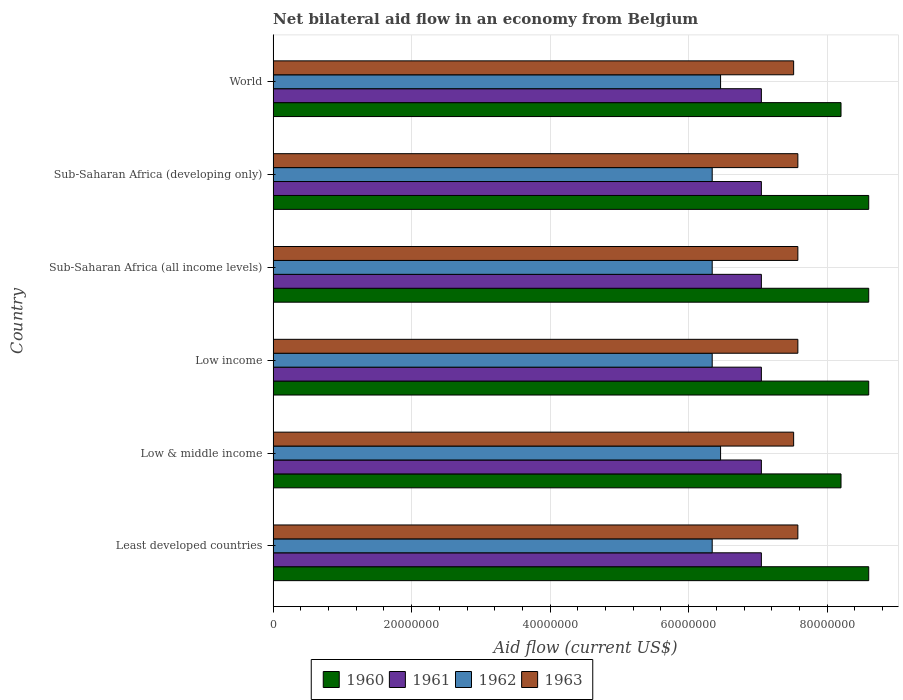How many different coloured bars are there?
Offer a terse response. 4. How many groups of bars are there?
Your response must be concise. 6. Are the number of bars on each tick of the Y-axis equal?
Keep it short and to the point. Yes. What is the label of the 3rd group of bars from the top?
Offer a very short reply. Sub-Saharan Africa (all income levels). What is the net bilateral aid flow in 1960 in Low income?
Your response must be concise. 8.60e+07. Across all countries, what is the maximum net bilateral aid flow in 1963?
Keep it short and to the point. 7.58e+07. Across all countries, what is the minimum net bilateral aid flow in 1960?
Provide a short and direct response. 8.20e+07. In which country was the net bilateral aid flow in 1960 maximum?
Ensure brevity in your answer.  Least developed countries. In which country was the net bilateral aid flow in 1960 minimum?
Your answer should be compact. Low & middle income. What is the total net bilateral aid flow in 1963 in the graph?
Your answer should be very brief. 4.53e+08. What is the difference between the net bilateral aid flow in 1961 in World and the net bilateral aid flow in 1962 in Low income?
Provide a succinct answer. 7.10e+06. What is the average net bilateral aid flow in 1962 per country?
Your response must be concise. 6.38e+07. What is the difference between the net bilateral aid flow in 1962 and net bilateral aid flow in 1960 in Sub-Saharan Africa (all income levels)?
Keep it short and to the point. -2.26e+07. In how many countries, is the net bilateral aid flow in 1962 greater than 72000000 US$?
Ensure brevity in your answer.  0. Is the difference between the net bilateral aid flow in 1962 in Sub-Saharan Africa (all income levels) and World greater than the difference between the net bilateral aid flow in 1960 in Sub-Saharan Africa (all income levels) and World?
Your answer should be very brief. No. What is the difference between the highest and the second highest net bilateral aid flow in 1961?
Give a very brief answer. 0. What is the difference between the highest and the lowest net bilateral aid flow in 1962?
Offer a terse response. 1.21e+06. Is the sum of the net bilateral aid flow in 1962 in Sub-Saharan Africa (all income levels) and World greater than the maximum net bilateral aid flow in 1961 across all countries?
Make the answer very short. Yes. What does the 4th bar from the top in Sub-Saharan Africa (developing only) represents?
Your response must be concise. 1960. Are all the bars in the graph horizontal?
Keep it short and to the point. Yes. What is the difference between two consecutive major ticks on the X-axis?
Your answer should be very brief. 2.00e+07. Does the graph contain grids?
Offer a terse response. Yes. Where does the legend appear in the graph?
Make the answer very short. Bottom center. How many legend labels are there?
Keep it short and to the point. 4. How are the legend labels stacked?
Give a very brief answer. Horizontal. What is the title of the graph?
Give a very brief answer. Net bilateral aid flow in an economy from Belgium. Does "1991" appear as one of the legend labels in the graph?
Provide a short and direct response. No. What is the label or title of the Y-axis?
Provide a succinct answer. Country. What is the Aid flow (current US$) of 1960 in Least developed countries?
Provide a short and direct response. 8.60e+07. What is the Aid flow (current US$) of 1961 in Least developed countries?
Provide a succinct answer. 7.05e+07. What is the Aid flow (current US$) of 1962 in Least developed countries?
Make the answer very short. 6.34e+07. What is the Aid flow (current US$) of 1963 in Least developed countries?
Ensure brevity in your answer.  7.58e+07. What is the Aid flow (current US$) of 1960 in Low & middle income?
Ensure brevity in your answer.  8.20e+07. What is the Aid flow (current US$) of 1961 in Low & middle income?
Offer a very short reply. 7.05e+07. What is the Aid flow (current US$) in 1962 in Low & middle income?
Provide a short and direct response. 6.46e+07. What is the Aid flow (current US$) of 1963 in Low & middle income?
Provide a succinct answer. 7.52e+07. What is the Aid flow (current US$) in 1960 in Low income?
Ensure brevity in your answer.  8.60e+07. What is the Aid flow (current US$) in 1961 in Low income?
Give a very brief answer. 7.05e+07. What is the Aid flow (current US$) in 1962 in Low income?
Ensure brevity in your answer.  6.34e+07. What is the Aid flow (current US$) of 1963 in Low income?
Ensure brevity in your answer.  7.58e+07. What is the Aid flow (current US$) of 1960 in Sub-Saharan Africa (all income levels)?
Provide a succinct answer. 8.60e+07. What is the Aid flow (current US$) in 1961 in Sub-Saharan Africa (all income levels)?
Make the answer very short. 7.05e+07. What is the Aid flow (current US$) of 1962 in Sub-Saharan Africa (all income levels)?
Your answer should be compact. 6.34e+07. What is the Aid flow (current US$) in 1963 in Sub-Saharan Africa (all income levels)?
Provide a succinct answer. 7.58e+07. What is the Aid flow (current US$) in 1960 in Sub-Saharan Africa (developing only)?
Give a very brief answer. 8.60e+07. What is the Aid flow (current US$) in 1961 in Sub-Saharan Africa (developing only)?
Your answer should be very brief. 7.05e+07. What is the Aid flow (current US$) in 1962 in Sub-Saharan Africa (developing only)?
Keep it short and to the point. 6.34e+07. What is the Aid flow (current US$) of 1963 in Sub-Saharan Africa (developing only)?
Your answer should be very brief. 7.58e+07. What is the Aid flow (current US$) in 1960 in World?
Make the answer very short. 8.20e+07. What is the Aid flow (current US$) in 1961 in World?
Provide a succinct answer. 7.05e+07. What is the Aid flow (current US$) in 1962 in World?
Keep it short and to the point. 6.46e+07. What is the Aid flow (current US$) in 1963 in World?
Provide a short and direct response. 7.52e+07. Across all countries, what is the maximum Aid flow (current US$) in 1960?
Provide a succinct answer. 8.60e+07. Across all countries, what is the maximum Aid flow (current US$) of 1961?
Your answer should be compact. 7.05e+07. Across all countries, what is the maximum Aid flow (current US$) in 1962?
Keep it short and to the point. 6.46e+07. Across all countries, what is the maximum Aid flow (current US$) of 1963?
Give a very brief answer. 7.58e+07. Across all countries, what is the minimum Aid flow (current US$) in 1960?
Give a very brief answer. 8.20e+07. Across all countries, what is the minimum Aid flow (current US$) of 1961?
Offer a very short reply. 7.05e+07. Across all countries, what is the minimum Aid flow (current US$) of 1962?
Offer a very short reply. 6.34e+07. Across all countries, what is the minimum Aid flow (current US$) of 1963?
Make the answer very short. 7.52e+07. What is the total Aid flow (current US$) in 1960 in the graph?
Provide a succinct answer. 5.08e+08. What is the total Aid flow (current US$) of 1961 in the graph?
Provide a short and direct response. 4.23e+08. What is the total Aid flow (current US$) of 1962 in the graph?
Keep it short and to the point. 3.83e+08. What is the total Aid flow (current US$) in 1963 in the graph?
Provide a succinct answer. 4.53e+08. What is the difference between the Aid flow (current US$) in 1961 in Least developed countries and that in Low & middle income?
Your response must be concise. 0. What is the difference between the Aid flow (current US$) of 1962 in Least developed countries and that in Low & middle income?
Make the answer very short. -1.21e+06. What is the difference between the Aid flow (current US$) of 1960 in Least developed countries and that in Low income?
Your answer should be very brief. 0. What is the difference between the Aid flow (current US$) in 1961 in Least developed countries and that in Low income?
Make the answer very short. 0. What is the difference between the Aid flow (current US$) of 1962 in Least developed countries and that in Low income?
Provide a short and direct response. 0. What is the difference between the Aid flow (current US$) of 1963 in Least developed countries and that in Low income?
Keep it short and to the point. 0. What is the difference between the Aid flow (current US$) in 1960 in Least developed countries and that in Sub-Saharan Africa (all income levels)?
Offer a very short reply. 0. What is the difference between the Aid flow (current US$) in 1962 in Least developed countries and that in Sub-Saharan Africa (all income levels)?
Your answer should be compact. 0. What is the difference between the Aid flow (current US$) in 1960 in Least developed countries and that in Sub-Saharan Africa (developing only)?
Your response must be concise. 0. What is the difference between the Aid flow (current US$) in 1961 in Least developed countries and that in Sub-Saharan Africa (developing only)?
Keep it short and to the point. 0. What is the difference between the Aid flow (current US$) in 1960 in Least developed countries and that in World?
Offer a very short reply. 4.00e+06. What is the difference between the Aid flow (current US$) of 1961 in Least developed countries and that in World?
Offer a very short reply. 0. What is the difference between the Aid flow (current US$) of 1962 in Least developed countries and that in World?
Your answer should be compact. -1.21e+06. What is the difference between the Aid flow (current US$) in 1960 in Low & middle income and that in Low income?
Your response must be concise. -4.00e+06. What is the difference between the Aid flow (current US$) of 1962 in Low & middle income and that in Low income?
Ensure brevity in your answer.  1.21e+06. What is the difference between the Aid flow (current US$) in 1963 in Low & middle income and that in Low income?
Give a very brief answer. -6.10e+05. What is the difference between the Aid flow (current US$) in 1962 in Low & middle income and that in Sub-Saharan Africa (all income levels)?
Provide a short and direct response. 1.21e+06. What is the difference between the Aid flow (current US$) in 1963 in Low & middle income and that in Sub-Saharan Africa (all income levels)?
Provide a short and direct response. -6.10e+05. What is the difference between the Aid flow (current US$) of 1961 in Low & middle income and that in Sub-Saharan Africa (developing only)?
Offer a very short reply. 0. What is the difference between the Aid flow (current US$) of 1962 in Low & middle income and that in Sub-Saharan Africa (developing only)?
Your response must be concise. 1.21e+06. What is the difference between the Aid flow (current US$) of 1963 in Low & middle income and that in Sub-Saharan Africa (developing only)?
Offer a very short reply. -6.10e+05. What is the difference between the Aid flow (current US$) in 1960 in Low & middle income and that in World?
Provide a succinct answer. 0. What is the difference between the Aid flow (current US$) in 1963 in Low & middle income and that in World?
Offer a terse response. 0. What is the difference between the Aid flow (current US$) of 1961 in Low income and that in Sub-Saharan Africa (all income levels)?
Provide a short and direct response. 0. What is the difference between the Aid flow (current US$) of 1962 in Low income and that in Sub-Saharan Africa (all income levels)?
Ensure brevity in your answer.  0. What is the difference between the Aid flow (current US$) in 1960 in Low income and that in Sub-Saharan Africa (developing only)?
Your response must be concise. 0. What is the difference between the Aid flow (current US$) in 1962 in Low income and that in Sub-Saharan Africa (developing only)?
Provide a succinct answer. 0. What is the difference between the Aid flow (current US$) of 1963 in Low income and that in Sub-Saharan Africa (developing only)?
Your response must be concise. 0. What is the difference between the Aid flow (current US$) of 1961 in Low income and that in World?
Provide a short and direct response. 0. What is the difference between the Aid flow (current US$) in 1962 in Low income and that in World?
Your response must be concise. -1.21e+06. What is the difference between the Aid flow (current US$) in 1960 in Sub-Saharan Africa (all income levels) and that in Sub-Saharan Africa (developing only)?
Provide a short and direct response. 0. What is the difference between the Aid flow (current US$) of 1961 in Sub-Saharan Africa (all income levels) and that in Sub-Saharan Africa (developing only)?
Your answer should be very brief. 0. What is the difference between the Aid flow (current US$) in 1962 in Sub-Saharan Africa (all income levels) and that in Sub-Saharan Africa (developing only)?
Provide a short and direct response. 0. What is the difference between the Aid flow (current US$) in 1963 in Sub-Saharan Africa (all income levels) and that in Sub-Saharan Africa (developing only)?
Ensure brevity in your answer.  0. What is the difference between the Aid flow (current US$) in 1961 in Sub-Saharan Africa (all income levels) and that in World?
Your response must be concise. 0. What is the difference between the Aid flow (current US$) of 1962 in Sub-Saharan Africa (all income levels) and that in World?
Your answer should be very brief. -1.21e+06. What is the difference between the Aid flow (current US$) of 1960 in Sub-Saharan Africa (developing only) and that in World?
Offer a very short reply. 4.00e+06. What is the difference between the Aid flow (current US$) of 1962 in Sub-Saharan Africa (developing only) and that in World?
Provide a succinct answer. -1.21e+06. What is the difference between the Aid flow (current US$) in 1963 in Sub-Saharan Africa (developing only) and that in World?
Provide a succinct answer. 6.10e+05. What is the difference between the Aid flow (current US$) in 1960 in Least developed countries and the Aid flow (current US$) in 1961 in Low & middle income?
Offer a terse response. 1.55e+07. What is the difference between the Aid flow (current US$) in 1960 in Least developed countries and the Aid flow (current US$) in 1962 in Low & middle income?
Your answer should be very brief. 2.14e+07. What is the difference between the Aid flow (current US$) in 1960 in Least developed countries and the Aid flow (current US$) in 1963 in Low & middle income?
Your answer should be compact. 1.08e+07. What is the difference between the Aid flow (current US$) in 1961 in Least developed countries and the Aid flow (current US$) in 1962 in Low & middle income?
Offer a terse response. 5.89e+06. What is the difference between the Aid flow (current US$) of 1961 in Least developed countries and the Aid flow (current US$) of 1963 in Low & middle income?
Make the answer very short. -4.66e+06. What is the difference between the Aid flow (current US$) in 1962 in Least developed countries and the Aid flow (current US$) in 1963 in Low & middle income?
Your answer should be compact. -1.18e+07. What is the difference between the Aid flow (current US$) in 1960 in Least developed countries and the Aid flow (current US$) in 1961 in Low income?
Provide a short and direct response. 1.55e+07. What is the difference between the Aid flow (current US$) of 1960 in Least developed countries and the Aid flow (current US$) of 1962 in Low income?
Offer a terse response. 2.26e+07. What is the difference between the Aid flow (current US$) in 1960 in Least developed countries and the Aid flow (current US$) in 1963 in Low income?
Your response must be concise. 1.02e+07. What is the difference between the Aid flow (current US$) in 1961 in Least developed countries and the Aid flow (current US$) in 1962 in Low income?
Provide a succinct answer. 7.10e+06. What is the difference between the Aid flow (current US$) of 1961 in Least developed countries and the Aid flow (current US$) of 1963 in Low income?
Give a very brief answer. -5.27e+06. What is the difference between the Aid flow (current US$) of 1962 in Least developed countries and the Aid flow (current US$) of 1963 in Low income?
Your response must be concise. -1.24e+07. What is the difference between the Aid flow (current US$) of 1960 in Least developed countries and the Aid flow (current US$) of 1961 in Sub-Saharan Africa (all income levels)?
Ensure brevity in your answer.  1.55e+07. What is the difference between the Aid flow (current US$) in 1960 in Least developed countries and the Aid flow (current US$) in 1962 in Sub-Saharan Africa (all income levels)?
Provide a short and direct response. 2.26e+07. What is the difference between the Aid flow (current US$) of 1960 in Least developed countries and the Aid flow (current US$) of 1963 in Sub-Saharan Africa (all income levels)?
Keep it short and to the point. 1.02e+07. What is the difference between the Aid flow (current US$) of 1961 in Least developed countries and the Aid flow (current US$) of 1962 in Sub-Saharan Africa (all income levels)?
Your response must be concise. 7.10e+06. What is the difference between the Aid flow (current US$) of 1961 in Least developed countries and the Aid flow (current US$) of 1963 in Sub-Saharan Africa (all income levels)?
Ensure brevity in your answer.  -5.27e+06. What is the difference between the Aid flow (current US$) of 1962 in Least developed countries and the Aid flow (current US$) of 1963 in Sub-Saharan Africa (all income levels)?
Keep it short and to the point. -1.24e+07. What is the difference between the Aid flow (current US$) of 1960 in Least developed countries and the Aid flow (current US$) of 1961 in Sub-Saharan Africa (developing only)?
Your response must be concise. 1.55e+07. What is the difference between the Aid flow (current US$) of 1960 in Least developed countries and the Aid flow (current US$) of 1962 in Sub-Saharan Africa (developing only)?
Provide a short and direct response. 2.26e+07. What is the difference between the Aid flow (current US$) of 1960 in Least developed countries and the Aid flow (current US$) of 1963 in Sub-Saharan Africa (developing only)?
Your response must be concise. 1.02e+07. What is the difference between the Aid flow (current US$) of 1961 in Least developed countries and the Aid flow (current US$) of 1962 in Sub-Saharan Africa (developing only)?
Offer a very short reply. 7.10e+06. What is the difference between the Aid flow (current US$) in 1961 in Least developed countries and the Aid flow (current US$) in 1963 in Sub-Saharan Africa (developing only)?
Your answer should be very brief. -5.27e+06. What is the difference between the Aid flow (current US$) of 1962 in Least developed countries and the Aid flow (current US$) of 1963 in Sub-Saharan Africa (developing only)?
Your response must be concise. -1.24e+07. What is the difference between the Aid flow (current US$) in 1960 in Least developed countries and the Aid flow (current US$) in 1961 in World?
Offer a very short reply. 1.55e+07. What is the difference between the Aid flow (current US$) of 1960 in Least developed countries and the Aid flow (current US$) of 1962 in World?
Keep it short and to the point. 2.14e+07. What is the difference between the Aid flow (current US$) of 1960 in Least developed countries and the Aid flow (current US$) of 1963 in World?
Provide a succinct answer. 1.08e+07. What is the difference between the Aid flow (current US$) of 1961 in Least developed countries and the Aid flow (current US$) of 1962 in World?
Make the answer very short. 5.89e+06. What is the difference between the Aid flow (current US$) in 1961 in Least developed countries and the Aid flow (current US$) in 1963 in World?
Ensure brevity in your answer.  -4.66e+06. What is the difference between the Aid flow (current US$) of 1962 in Least developed countries and the Aid flow (current US$) of 1963 in World?
Give a very brief answer. -1.18e+07. What is the difference between the Aid flow (current US$) in 1960 in Low & middle income and the Aid flow (current US$) in 1961 in Low income?
Offer a terse response. 1.15e+07. What is the difference between the Aid flow (current US$) in 1960 in Low & middle income and the Aid flow (current US$) in 1962 in Low income?
Make the answer very short. 1.86e+07. What is the difference between the Aid flow (current US$) of 1960 in Low & middle income and the Aid flow (current US$) of 1963 in Low income?
Offer a very short reply. 6.23e+06. What is the difference between the Aid flow (current US$) of 1961 in Low & middle income and the Aid flow (current US$) of 1962 in Low income?
Ensure brevity in your answer.  7.10e+06. What is the difference between the Aid flow (current US$) in 1961 in Low & middle income and the Aid flow (current US$) in 1963 in Low income?
Provide a short and direct response. -5.27e+06. What is the difference between the Aid flow (current US$) in 1962 in Low & middle income and the Aid flow (current US$) in 1963 in Low income?
Provide a succinct answer. -1.12e+07. What is the difference between the Aid flow (current US$) in 1960 in Low & middle income and the Aid flow (current US$) in 1961 in Sub-Saharan Africa (all income levels)?
Ensure brevity in your answer.  1.15e+07. What is the difference between the Aid flow (current US$) in 1960 in Low & middle income and the Aid flow (current US$) in 1962 in Sub-Saharan Africa (all income levels)?
Ensure brevity in your answer.  1.86e+07. What is the difference between the Aid flow (current US$) of 1960 in Low & middle income and the Aid flow (current US$) of 1963 in Sub-Saharan Africa (all income levels)?
Provide a succinct answer. 6.23e+06. What is the difference between the Aid flow (current US$) of 1961 in Low & middle income and the Aid flow (current US$) of 1962 in Sub-Saharan Africa (all income levels)?
Give a very brief answer. 7.10e+06. What is the difference between the Aid flow (current US$) of 1961 in Low & middle income and the Aid flow (current US$) of 1963 in Sub-Saharan Africa (all income levels)?
Offer a very short reply. -5.27e+06. What is the difference between the Aid flow (current US$) in 1962 in Low & middle income and the Aid flow (current US$) in 1963 in Sub-Saharan Africa (all income levels)?
Ensure brevity in your answer.  -1.12e+07. What is the difference between the Aid flow (current US$) of 1960 in Low & middle income and the Aid flow (current US$) of 1961 in Sub-Saharan Africa (developing only)?
Offer a very short reply. 1.15e+07. What is the difference between the Aid flow (current US$) of 1960 in Low & middle income and the Aid flow (current US$) of 1962 in Sub-Saharan Africa (developing only)?
Make the answer very short. 1.86e+07. What is the difference between the Aid flow (current US$) in 1960 in Low & middle income and the Aid flow (current US$) in 1963 in Sub-Saharan Africa (developing only)?
Your response must be concise. 6.23e+06. What is the difference between the Aid flow (current US$) in 1961 in Low & middle income and the Aid flow (current US$) in 1962 in Sub-Saharan Africa (developing only)?
Ensure brevity in your answer.  7.10e+06. What is the difference between the Aid flow (current US$) of 1961 in Low & middle income and the Aid flow (current US$) of 1963 in Sub-Saharan Africa (developing only)?
Your answer should be compact. -5.27e+06. What is the difference between the Aid flow (current US$) in 1962 in Low & middle income and the Aid flow (current US$) in 1963 in Sub-Saharan Africa (developing only)?
Provide a short and direct response. -1.12e+07. What is the difference between the Aid flow (current US$) of 1960 in Low & middle income and the Aid flow (current US$) of 1961 in World?
Your answer should be compact. 1.15e+07. What is the difference between the Aid flow (current US$) in 1960 in Low & middle income and the Aid flow (current US$) in 1962 in World?
Your response must be concise. 1.74e+07. What is the difference between the Aid flow (current US$) of 1960 in Low & middle income and the Aid flow (current US$) of 1963 in World?
Keep it short and to the point. 6.84e+06. What is the difference between the Aid flow (current US$) of 1961 in Low & middle income and the Aid flow (current US$) of 1962 in World?
Keep it short and to the point. 5.89e+06. What is the difference between the Aid flow (current US$) of 1961 in Low & middle income and the Aid flow (current US$) of 1963 in World?
Ensure brevity in your answer.  -4.66e+06. What is the difference between the Aid flow (current US$) in 1962 in Low & middle income and the Aid flow (current US$) in 1963 in World?
Your response must be concise. -1.06e+07. What is the difference between the Aid flow (current US$) of 1960 in Low income and the Aid flow (current US$) of 1961 in Sub-Saharan Africa (all income levels)?
Ensure brevity in your answer.  1.55e+07. What is the difference between the Aid flow (current US$) of 1960 in Low income and the Aid flow (current US$) of 1962 in Sub-Saharan Africa (all income levels)?
Offer a terse response. 2.26e+07. What is the difference between the Aid flow (current US$) of 1960 in Low income and the Aid flow (current US$) of 1963 in Sub-Saharan Africa (all income levels)?
Your response must be concise. 1.02e+07. What is the difference between the Aid flow (current US$) in 1961 in Low income and the Aid flow (current US$) in 1962 in Sub-Saharan Africa (all income levels)?
Offer a very short reply. 7.10e+06. What is the difference between the Aid flow (current US$) in 1961 in Low income and the Aid flow (current US$) in 1963 in Sub-Saharan Africa (all income levels)?
Offer a very short reply. -5.27e+06. What is the difference between the Aid flow (current US$) in 1962 in Low income and the Aid flow (current US$) in 1963 in Sub-Saharan Africa (all income levels)?
Your answer should be very brief. -1.24e+07. What is the difference between the Aid flow (current US$) in 1960 in Low income and the Aid flow (current US$) in 1961 in Sub-Saharan Africa (developing only)?
Give a very brief answer. 1.55e+07. What is the difference between the Aid flow (current US$) in 1960 in Low income and the Aid flow (current US$) in 1962 in Sub-Saharan Africa (developing only)?
Ensure brevity in your answer.  2.26e+07. What is the difference between the Aid flow (current US$) in 1960 in Low income and the Aid flow (current US$) in 1963 in Sub-Saharan Africa (developing only)?
Offer a terse response. 1.02e+07. What is the difference between the Aid flow (current US$) in 1961 in Low income and the Aid flow (current US$) in 1962 in Sub-Saharan Africa (developing only)?
Offer a very short reply. 7.10e+06. What is the difference between the Aid flow (current US$) of 1961 in Low income and the Aid flow (current US$) of 1963 in Sub-Saharan Africa (developing only)?
Your answer should be compact. -5.27e+06. What is the difference between the Aid flow (current US$) of 1962 in Low income and the Aid flow (current US$) of 1963 in Sub-Saharan Africa (developing only)?
Ensure brevity in your answer.  -1.24e+07. What is the difference between the Aid flow (current US$) in 1960 in Low income and the Aid flow (current US$) in 1961 in World?
Ensure brevity in your answer.  1.55e+07. What is the difference between the Aid flow (current US$) in 1960 in Low income and the Aid flow (current US$) in 1962 in World?
Give a very brief answer. 2.14e+07. What is the difference between the Aid flow (current US$) in 1960 in Low income and the Aid flow (current US$) in 1963 in World?
Give a very brief answer. 1.08e+07. What is the difference between the Aid flow (current US$) of 1961 in Low income and the Aid flow (current US$) of 1962 in World?
Give a very brief answer. 5.89e+06. What is the difference between the Aid flow (current US$) of 1961 in Low income and the Aid flow (current US$) of 1963 in World?
Ensure brevity in your answer.  -4.66e+06. What is the difference between the Aid flow (current US$) in 1962 in Low income and the Aid flow (current US$) in 1963 in World?
Your answer should be compact. -1.18e+07. What is the difference between the Aid flow (current US$) in 1960 in Sub-Saharan Africa (all income levels) and the Aid flow (current US$) in 1961 in Sub-Saharan Africa (developing only)?
Offer a very short reply. 1.55e+07. What is the difference between the Aid flow (current US$) in 1960 in Sub-Saharan Africa (all income levels) and the Aid flow (current US$) in 1962 in Sub-Saharan Africa (developing only)?
Your response must be concise. 2.26e+07. What is the difference between the Aid flow (current US$) of 1960 in Sub-Saharan Africa (all income levels) and the Aid flow (current US$) of 1963 in Sub-Saharan Africa (developing only)?
Your answer should be very brief. 1.02e+07. What is the difference between the Aid flow (current US$) in 1961 in Sub-Saharan Africa (all income levels) and the Aid flow (current US$) in 1962 in Sub-Saharan Africa (developing only)?
Ensure brevity in your answer.  7.10e+06. What is the difference between the Aid flow (current US$) of 1961 in Sub-Saharan Africa (all income levels) and the Aid flow (current US$) of 1963 in Sub-Saharan Africa (developing only)?
Provide a succinct answer. -5.27e+06. What is the difference between the Aid flow (current US$) of 1962 in Sub-Saharan Africa (all income levels) and the Aid flow (current US$) of 1963 in Sub-Saharan Africa (developing only)?
Offer a terse response. -1.24e+07. What is the difference between the Aid flow (current US$) in 1960 in Sub-Saharan Africa (all income levels) and the Aid flow (current US$) in 1961 in World?
Keep it short and to the point. 1.55e+07. What is the difference between the Aid flow (current US$) of 1960 in Sub-Saharan Africa (all income levels) and the Aid flow (current US$) of 1962 in World?
Keep it short and to the point. 2.14e+07. What is the difference between the Aid flow (current US$) of 1960 in Sub-Saharan Africa (all income levels) and the Aid flow (current US$) of 1963 in World?
Ensure brevity in your answer.  1.08e+07. What is the difference between the Aid flow (current US$) of 1961 in Sub-Saharan Africa (all income levels) and the Aid flow (current US$) of 1962 in World?
Your answer should be compact. 5.89e+06. What is the difference between the Aid flow (current US$) of 1961 in Sub-Saharan Africa (all income levels) and the Aid flow (current US$) of 1963 in World?
Your answer should be very brief. -4.66e+06. What is the difference between the Aid flow (current US$) in 1962 in Sub-Saharan Africa (all income levels) and the Aid flow (current US$) in 1963 in World?
Offer a very short reply. -1.18e+07. What is the difference between the Aid flow (current US$) in 1960 in Sub-Saharan Africa (developing only) and the Aid flow (current US$) in 1961 in World?
Your answer should be compact. 1.55e+07. What is the difference between the Aid flow (current US$) in 1960 in Sub-Saharan Africa (developing only) and the Aid flow (current US$) in 1962 in World?
Your answer should be very brief. 2.14e+07. What is the difference between the Aid flow (current US$) of 1960 in Sub-Saharan Africa (developing only) and the Aid flow (current US$) of 1963 in World?
Your response must be concise. 1.08e+07. What is the difference between the Aid flow (current US$) of 1961 in Sub-Saharan Africa (developing only) and the Aid flow (current US$) of 1962 in World?
Provide a succinct answer. 5.89e+06. What is the difference between the Aid flow (current US$) in 1961 in Sub-Saharan Africa (developing only) and the Aid flow (current US$) in 1963 in World?
Provide a succinct answer. -4.66e+06. What is the difference between the Aid flow (current US$) in 1962 in Sub-Saharan Africa (developing only) and the Aid flow (current US$) in 1963 in World?
Offer a terse response. -1.18e+07. What is the average Aid flow (current US$) in 1960 per country?
Give a very brief answer. 8.47e+07. What is the average Aid flow (current US$) of 1961 per country?
Keep it short and to the point. 7.05e+07. What is the average Aid flow (current US$) of 1962 per country?
Offer a very short reply. 6.38e+07. What is the average Aid flow (current US$) of 1963 per country?
Offer a terse response. 7.56e+07. What is the difference between the Aid flow (current US$) of 1960 and Aid flow (current US$) of 1961 in Least developed countries?
Offer a terse response. 1.55e+07. What is the difference between the Aid flow (current US$) of 1960 and Aid flow (current US$) of 1962 in Least developed countries?
Provide a succinct answer. 2.26e+07. What is the difference between the Aid flow (current US$) of 1960 and Aid flow (current US$) of 1963 in Least developed countries?
Offer a very short reply. 1.02e+07. What is the difference between the Aid flow (current US$) of 1961 and Aid flow (current US$) of 1962 in Least developed countries?
Make the answer very short. 7.10e+06. What is the difference between the Aid flow (current US$) of 1961 and Aid flow (current US$) of 1963 in Least developed countries?
Your answer should be very brief. -5.27e+06. What is the difference between the Aid flow (current US$) of 1962 and Aid flow (current US$) of 1963 in Least developed countries?
Give a very brief answer. -1.24e+07. What is the difference between the Aid flow (current US$) of 1960 and Aid flow (current US$) of 1961 in Low & middle income?
Ensure brevity in your answer.  1.15e+07. What is the difference between the Aid flow (current US$) of 1960 and Aid flow (current US$) of 1962 in Low & middle income?
Your answer should be very brief. 1.74e+07. What is the difference between the Aid flow (current US$) in 1960 and Aid flow (current US$) in 1963 in Low & middle income?
Make the answer very short. 6.84e+06. What is the difference between the Aid flow (current US$) of 1961 and Aid flow (current US$) of 1962 in Low & middle income?
Provide a short and direct response. 5.89e+06. What is the difference between the Aid flow (current US$) of 1961 and Aid flow (current US$) of 1963 in Low & middle income?
Offer a terse response. -4.66e+06. What is the difference between the Aid flow (current US$) of 1962 and Aid flow (current US$) of 1963 in Low & middle income?
Make the answer very short. -1.06e+07. What is the difference between the Aid flow (current US$) of 1960 and Aid flow (current US$) of 1961 in Low income?
Keep it short and to the point. 1.55e+07. What is the difference between the Aid flow (current US$) of 1960 and Aid flow (current US$) of 1962 in Low income?
Provide a short and direct response. 2.26e+07. What is the difference between the Aid flow (current US$) of 1960 and Aid flow (current US$) of 1963 in Low income?
Make the answer very short. 1.02e+07. What is the difference between the Aid flow (current US$) of 1961 and Aid flow (current US$) of 1962 in Low income?
Provide a short and direct response. 7.10e+06. What is the difference between the Aid flow (current US$) of 1961 and Aid flow (current US$) of 1963 in Low income?
Provide a succinct answer. -5.27e+06. What is the difference between the Aid flow (current US$) of 1962 and Aid flow (current US$) of 1963 in Low income?
Provide a succinct answer. -1.24e+07. What is the difference between the Aid flow (current US$) in 1960 and Aid flow (current US$) in 1961 in Sub-Saharan Africa (all income levels)?
Your answer should be very brief. 1.55e+07. What is the difference between the Aid flow (current US$) of 1960 and Aid flow (current US$) of 1962 in Sub-Saharan Africa (all income levels)?
Give a very brief answer. 2.26e+07. What is the difference between the Aid flow (current US$) in 1960 and Aid flow (current US$) in 1963 in Sub-Saharan Africa (all income levels)?
Your answer should be very brief. 1.02e+07. What is the difference between the Aid flow (current US$) of 1961 and Aid flow (current US$) of 1962 in Sub-Saharan Africa (all income levels)?
Provide a short and direct response. 7.10e+06. What is the difference between the Aid flow (current US$) in 1961 and Aid flow (current US$) in 1963 in Sub-Saharan Africa (all income levels)?
Make the answer very short. -5.27e+06. What is the difference between the Aid flow (current US$) of 1962 and Aid flow (current US$) of 1963 in Sub-Saharan Africa (all income levels)?
Ensure brevity in your answer.  -1.24e+07. What is the difference between the Aid flow (current US$) of 1960 and Aid flow (current US$) of 1961 in Sub-Saharan Africa (developing only)?
Ensure brevity in your answer.  1.55e+07. What is the difference between the Aid flow (current US$) of 1960 and Aid flow (current US$) of 1962 in Sub-Saharan Africa (developing only)?
Offer a terse response. 2.26e+07. What is the difference between the Aid flow (current US$) of 1960 and Aid flow (current US$) of 1963 in Sub-Saharan Africa (developing only)?
Make the answer very short. 1.02e+07. What is the difference between the Aid flow (current US$) of 1961 and Aid flow (current US$) of 1962 in Sub-Saharan Africa (developing only)?
Your answer should be very brief. 7.10e+06. What is the difference between the Aid flow (current US$) of 1961 and Aid flow (current US$) of 1963 in Sub-Saharan Africa (developing only)?
Give a very brief answer. -5.27e+06. What is the difference between the Aid flow (current US$) of 1962 and Aid flow (current US$) of 1963 in Sub-Saharan Africa (developing only)?
Ensure brevity in your answer.  -1.24e+07. What is the difference between the Aid flow (current US$) of 1960 and Aid flow (current US$) of 1961 in World?
Your response must be concise. 1.15e+07. What is the difference between the Aid flow (current US$) in 1960 and Aid flow (current US$) in 1962 in World?
Offer a terse response. 1.74e+07. What is the difference between the Aid flow (current US$) of 1960 and Aid flow (current US$) of 1963 in World?
Make the answer very short. 6.84e+06. What is the difference between the Aid flow (current US$) in 1961 and Aid flow (current US$) in 1962 in World?
Ensure brevity in your answer.  5.89e+06. What is the difference between the Aid flow (current US$) in 1961 and Aid flow (current US$) in 1963 in World?
Keep it short and to the point. -4.66e+06. What is the difference between the Aid flow (current US$) of 1962 and Aid flow (current US$) of 1963 in World?
Your answer should be compact. -1.06e+07. What is the ratio of the Aid flow (current US$) of 1960 in Least developed countries to that in Low & middle income?
Give a very brief answer. 1.05. What is the ratio of the Aid flow (current US$) in 1962 in Least developed countries to that in Low & middle income?
Offer a terse response. 0.98. What is the ratio of the Aid flow (current US$) in 1963 in Least developed countries to that in Low & middle income?
Your answer should be very brief. 1.01. What is the ratio of the Aid flow (current US$) of 1960 in Least developed countries to that in Low income?
Give a very brief answer. 1. What is the ratio of the Aid flow (current US$) of 1962 in Least developed countries to that in Low income?
Your response must be concise. 1. What is the ratio of the Aid flow (current US$) of 1963 in Least developed countries to that in Low income?
Your response must be concise. 1. What is the ratio of the Aid flow (current US$) of 1960 in Least developed countries to that in Sub-Saharan Africa (all income levels)?
Provide a succinct answer. 1. What is the ratio of the Aid flow (current US$) of 1961 in Least developed countries to that in Sub-Saharan Africa (all income levels)?
Make the answer very short. 1. What is the ratio of the Aid flow (current US$) of 1962 in Least developed countries to that in Sub-Saharan Africa (all income levels)?
Your answer should be compact. 1. What is the ratio of the Aid flow (current US$) in 1963 in Least developed countries to that in Sub-Saharan Africa (all income levels)?
Keep it short and to the point. 1. What is the ratio of the Aid flow (current US$) in 1960 in Least developed countries to that in World?
Make the answer very short. 1.05. What is the ratio of the Aid flow (current US$) in 1961 in Least developed countries to that in World?
Provide a short and direct response. 1. What is the ratio of the Aid flow (current US$) in 1962 in Least developed countries to that in World?
Provide a short and direct response. 0.98. What is the ratio of the Aid flow (current US$) in 1960 in Low & middle income to that in Low income?
Your response must be concise. 0.95. What is the ratio of the Aid flow (current US$) of 1961 in Low & middle income to that in Low income?
Make the answer very short. 1. What is the ratio of the Aid flow (current US$) of 1962 in Low & middle income to that in Low income?
Offer a very short reply. 1.02. What is the ratio of the Aid flow (current US$) of 1960 in Low & middle income to that in Sub-Saharan Africa (all income levels)?
Provide a succinct answer. 0.95. What is the ratio of the Aid flow (current US$) of 1961 in Low & middle income to that in Sub-Saharan Africa (all income levels)?
Provide a short and direct response. 1. What is the ratio of the Aid flow (current US$) of 1962 in Low & middle income to that in Sub-Saharan Africa (all income levels)?
Make the answer very short. 1.02. What is the ratio of the Aid flow (current US$) in 1960 in Low & middle income to that in Sub-Saharan Africa (developing only)?
Offer a terse response. 0.95. What is the ratio of the Aid flow (current US$) in 1962 in Low & middle income to that in Sub-Saharan Africa (developing only)?
Offer a terse response. 1.02. What is the ratio of the Aid flow (current US$) of 1963 in Low & middle income to that in Sub-Saharan Africa (developing only)?
Offer a very short reply. 0.99. What is the ratio of the Aid flow (current US$) in 1963 in Low & middle income to that in World?
Your response must be concise. 1. What is the ratio of the Aid flow (current US$) in 1963 in Low income to that in Sub-Saharan Africa (all income levels)?
Your answer should be compact. 1. What is the ratio of the Aid flow (current US$) in 1960 in Low income to that in Sub-Saharan Africa (developing only)?
Keep it short and to the point. 1. What is the ratio of the Aid flow (current US$) of 1961 in Low income to that in Sub-Saharan Africa (developing only)?
Make the answer very short. 1. What is the ratio of the Aid flow (current US$) of 1962 in Low income to that in Sub-Saharan Africa (developing only)?
Offer a terse response. 1. What is the ratio of the Aid flow (current US$) of 1963 in Low income to that in Sub-Saharan Africa (developing only)?
Offer a terse response. 1. What is the ratio of the Aid flow (current US$) of 1960 in Low income to that in World?
Give a very brief answer. 1.05. What is the ratio of the Aid flow (current US$) in 1961 in Low income to that in World?
Make the answer very short. 1. What is the ratio of the Aid flow (current US$) of 1962 in Low income to that in World?
Provide a short and direct response. 0.98. What is the ratio of the Aid flow (current US$) in 1963 in Low income to that in World?
Make the answer very short. 1.01. What is the ratio of the Aid flow (current US$) in 1960 in Sub-Saharan Africa (all income levels) to that in Sub-Saharan Africa (developing only)?
Provide a succinct answer. 1. What is the ratio of the Aid flow (current US$) of 1960 in Sub-Saharan Africa (all income levels) to that in World?
Keep it short and to the point. 1.05. What is the ratio of the Aid flow (current US$) of 1961 in Sub-Saharan Africa (all income levels) to that in World?
Provide a short and direct response. 1. What is the ratio of the Aid flow (current US$) of 1962 in Sub-Saharan Africa (all income levels) to that in World?
Ensure brevity in your answer.  0.98. What is the ratio of the Aid flow (current US$) in 1960 in Sub-Saharan Africa (developing only) to that in World?
Your answer should be very brief. 1.05. What is the ratio of the Aid flow (current US$) of 1961 in Sub-Saharan Africa (developing only) to that in World?
Offer a terse response. 1. What is the ratio of the Aid flow (current US$) of 1962 in Sub-Saharan Africa (developing only) to that in World?
Make the answer very short. 0.98. What is the difference between the highest and the second highest Aid flow (current US$) of 1961?
Provide a succinct answer. 0. What is the difference between the highest and the second highest Aid flow (current US$) in 1962?
Ensure brevity in your answer.  0. What is the difference between the highest and the lowest Aid flow (current US$) of 1960?
Ensure brevity in your answer.  4.00e+06. What is the difference between the highest and the lowest Aid flow (current US$) of 1962?
Provide a short and direct response. 1.21e+06. What is the difference between the highest and the lowest Aid flow (current US$) of 1963?
Make the answer very short. 6.10e+05. 